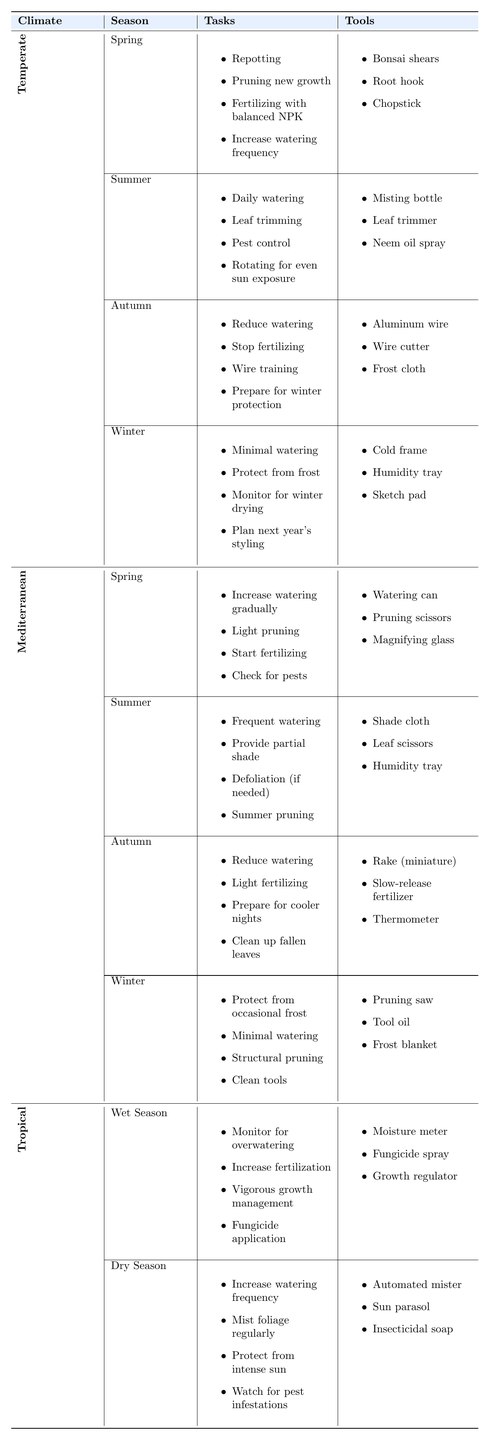What tasks are required for bonsai trees during the summer in temperate climates? According to the table, for summer in temperate climates, the tasks include daily watering, leaf trimming, pest control, and rotating for even sun exposure.
Answer: Daily watering, leaf trimming, pest control, and rotating for even sun exposure What tools are needed for autumn care of bonsai trees in Mediterranean climates? The table indicates that in autumn for Mediterranean climates, the required tools include a miniature rake, slow-release fertilizer, and a thermometer.
Answer: Miniature rake, slow-release fertilizer, and thermometer How many seasons have specific tasks listed for tropical bonsai care? The table shows that tropical climates have two seasons listed: Wet Season and Dry Season, each with specific tasks. Since both seasons have tasks, that makes a total of two seasons.
Answer: Two seasons Is "structural pruning" required during winter for Mediterranean bonsai trees? The table does indicate that structural pruning is a task required in winter for Mediterranean bonsai care. Therefore, the statement is true.
Answer: Yes Which climate requires "protection from frost" during the winter? The table shows that both temperate and Mediterranean climates require protection from frost in winter.
Answer: Temperate and Mediterranean What is the difference in the number of tasks required for spring care in temperate and Mediterranean climates? Temperate spring requires four tasks (repotting, pruning new growth, fertilizing with balanced NPK, and increasing watering frequency), while Mediterranean spring requires four tasks (increasing watering gradually, light pruning, starting fertilizing, and checking for pests). The difference in the number of tasks is 0.
Answer: 0 Which tools are exclusively needed for wet season tropical bonsai care? From the table, the tools required for wet season tropical care include a moisture meter, fungicide spray, and growth regulator. None of these tools appear in other seasons listed.
Answer: Moisture meter, fungicide spray, and growth regulator How does the watering frequency change from tropical dry season to temperate spring? In tropical dry season, the task requires an increase in watering frequency, while in temperate spring, the task specifies to increase watering frequency as well. Both seasons require an increase, showing there is a consistent need for more water.
Answer: Consistent increase needed in both What is the primary concern during the wet season for tropical bonsai trees? The table specifies that during the wet season, the main concern is to monitor for overwatering which can lead to detrimental effects on the bonsai.
Answer: Monitor for overwatering In which season should bonsai owners in temperate climates prepare for winter protection? According to the table, in autumn, bonsai owners in temperate climates need to prepare for winter protection.
Answer: Autumn 